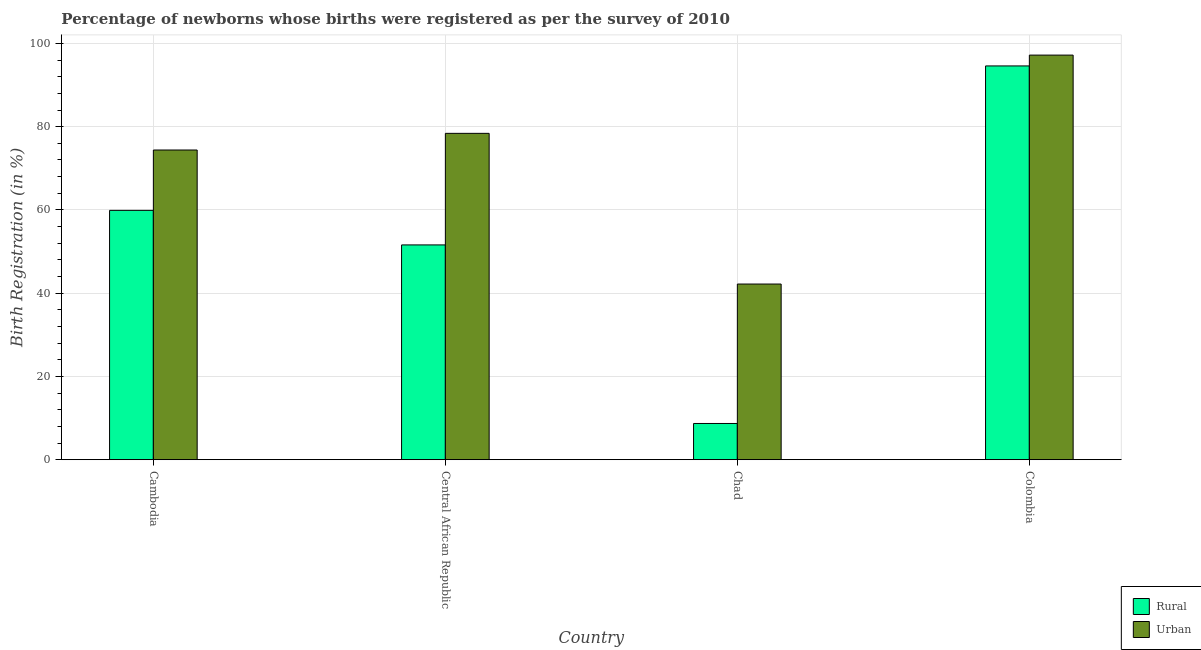How many different coloured bars are there?
Ensure brevity in your answer.  2. How many bars are there on the 3rd tick from the left?
Make the answer very short. 2. How many bars are there on the 3rd tick from the right?
Keep it short and to the point. 2. What is the label of the 3rd group of bars from the left?
Offer a terse response. Chad. What is the urban birth registration in Chad?
Provide a succinct answer. 42.2. Across all countries, what is the maximum urban birth registration?
Your answer should be very brief. 97.2. Across all countries, what is the minimum urban birth registration?
Give a very brief answer. 42.2. In which country was the urban birth registration maximum?
Your response must be concise. Colombia. In which country was the rural birth registration minimum?
Ensure brevity in your answer.  Chad. What is the total urban birth registration in the graph?
Keep it short and to the point. 292.2. What is the difference between the rural birth registration in Central African Republic and that in Chad?
Ensure brevity in your answer.  42.9. What is the difference between the urban birth registration in Cambodia and the rural birth registration in Central African Republic?
Your answer should be compact. 22.8. What is the average rural birth registration per country?
Provide a succinct answer. 53.7. What is the difference between the rural birth registration and urban birth registration in Central African Republic?
Offer a very short reply. -26.8. What is the ratio of the urban birth registration in Cambodia to that in Chad?
Keep it short and to the point. 1.76. Is the urban birth registration in Cambodia less than that in Chad?
Provide a succinct answer. No. Is the difference between the rural birth registration in Cambodia and Chad greater than the difference between the urban birth registration in Cambodia and Chad?
Ensure brevity in your answer.  Yes. What is the difference between the highest and the second highest rural birth registration?
Your response must be concise. 34.7. What is the difference between the highest and the lowest rural birth registration?
Offer a very short reply. 85.9. In how many countries, is the rural birth registration greater than the average rural birth registration taken over all countries?
Offer a terse response. 2. Is the sum of the urban birth registration in Central African Republic and Colombia greater than the maximum rural birth registration across all countries?
Provide a short and direct response. Yes. What does the 2nd bar from the left in Chad represents?
Offer a very short reply. Urban. What does the 1st bar from the right in Colombia represents?
Your answer should be very brief. Urban. Does the graph contain any zero values?
Give a very brief answer. No. How are the legend labels stacked?
Give a very brief answer. Vertical. What is the title of the graph?
Ensure brevity in your answer.  Percentage of newborns whose births were registered as per the survey of 2010. What is the label or title of the X-axis?
Give a very brief answer. Country. What is the label or title of the Y-axis?
Make the answer very short. Birth Registration (in %). What is the Birth Registration (in %) in Rural in Cambodia?
Provide a short and direct response. 59.9. What is the Birth Registration (in %) of Urban in Cambodia?
Provide a succinct answer. 74.4. What is the Birth Registration (in %) of Rural in Central African Republic?
Your answer should be very brief. 51.6. What is the Birth Registration (in %) of Urban in Central African Republic?
Keep it short and to the point. 78.4. What is the Birth Registration (in %) of Rural in Chad?
Give a very brief answer. 8.7. What is the Birth Registration (in %) of Urban in Chad?
Give a very brief answer. 42.2. What is the Birth Registration (in %) in Rural in Colombia?
Give a very brief answer. 94.6. What is the Birth Registration (in %) of Urban in Colombia?
Your answer should be very brief. 97.2. Across all countries, what is the maximum Birth Registration (in %) of Rural?
Make the answer very short. 94.6. Across all countries, what is the maximum Birth Registration (in %) of Urban?
Your answer should be very brief. 97.2. Across all countries, what is the minimum Birth Registration (in %) in Urban?
Provide a short and direct response. 42.2. What is the total Birth Registration (in %) in Rural in the graph?
Your answer should be compact. 214.8. What is the total Birth Registration (in %) of Urban in the graph?
Make the answer very short. 292.2. What is the difference between the Birth Registration (in %) of Rural in Cambodia and that in Chad?
Provide a short and direct response. 51.2. What is the difference between the Birth Registration (in %) in Urban in Cambodia and that in Chad?
Offer a very short reply. 32.2. What is the difference between the Birth Registration (in %) in Rural in Cambodia and that in Colombia?
Offer a very short reply. -34.7. What is the difference between the Birth Registration (in %) in Urban in Cambodia and that in Colombia?
Give a very brief answer. -22.8. What is the difference between the Birth Registration (in %) in Rural in Central African Republic and that in Chad?
Offer a terse response. 42.9. What is the difference between the Birth Registration (in %) in Urban in Central African Republic and that in Chad?
Your response must be concise. 36.2. What is the difference between the Birth Registration (in %) of Rural in Central African Republic and that in Colombia?
Offer a terse response. -43. What is the difference between the Birth Registration (in %) of Urban in Central African Republic and that in Colombia?
Your answer should be very brief. -18.8. What is the difference between the Birth Registration (in %) in Rural in Chad and that in Colombia?
Provide a succinct answer. -85.9. What is the difference between the Birth Registration (in %) of Urban in Chad and that in Colombia?
Your answer should be very brief. -55. What is the difference between the Birth Registration (in %) in Rural in Cambodia and the Birth Registration (in %) in Urban in Central African Republic?
Offer a terse response. -18.5. What is the difference between the Birth Registration (in %) in Rural in Cambodia and the Birth Registration (in %) in Urban in Chad?
Your response must be concise. 17.7. What is the difference between the Birth Registration (in %) of Rural in Cambodia and the Birth Registration (in %) of Urban in Colombia?
Your answer should be compact. -37.3. What is the difference between the Birth Registration (in %) in Rural in Central African Republic and the Birth Registration (in %) in Urban in Chad?
Keep it short and to the point. 9.4. What is the difference between the Birth Registration (in %) of Rural in Central African Republic and the Birth Registration (in %) of Urban in Colombia?
Keep it short and to the point. -45.6. What is the difference between the Birth Registration (in %) of Rural in Chad and the Birth Registration (in %) of Urban in Colombia?
Provide a short and direct response. -88.5. What is the average Birth Registration (in %) in Rural per country?
Your answer should be compact. 53.7. What is the average Birth Registration (in %) of Urban per country?
Your answer should be compact. 73.05. What is the difference between the Birth Registration (in %) of Rural and Birth Registration (in %) of Urban in Cambodia?
Ensure brevity in your answer.  -14.5. What is the difference between the Birth Registration (in %) in Rural and Birth Registration (in %) in Urban in Central African Republic?
Your answer should be very brief. -26.8. What is the difference between the Birth Registration (in %) of Rural and Birth Registration (in %) of Urban in Chad?
Give a very brief answer. -33.5. What is the ratio of the Birth Registration (in %) of Rural in Cambodia to that in Central African Republic?
Offer a terse response. 1.16. What is the ratio of the Birth Registration (in %) of Urban in Cambodia to that in Central African Republic?
Provide a succinct answer. 0.95. What is the ratio of the Birth Registration (in %) in Rural in Cambodia to that in Chad?
Give a very brief answer. 6.89. What is the ratio of the Birth Registration (in %) of Urban in Cambodia to that in Chad?
Make the answer very short. 1.76. What is the ratio of the Birth Registration (in %) of Rural in Cambodia to that in Colombia?
Make the answer very short. 0.63. What is the ratio of the Birth Registration (in %) in Urban in Cambodia to that in Colombia?
Offer a terse response. 0.77. What is the ratio of the Birth Registration (in %) of Rural in Central African Republic to that in Chad?
Ensure brevity in your answer.  5.93. What is the ratio of the Birth Registration (in %) of Urban in Central African Republic to that in Chad?
Offer a very short reply. 1.86. What is the ratio of the Birth Registration (in %) in Rural in Central African Republic to that in Colombia?
Provide a succinct answer. 0.55. What is the ratio of the Birth Registration (in %) in Urban in Central African Republic to that in Colombia?
Ensure brevity in your answer.  0.81. What is the ratio of the Birth Registration (in %) of Rural in Chad to that in Colombia?
Your answer should be very brief. 0.09. What is the ratio of the Birth Registration (in %) of Urban in Chad to that in Colombia?
Give a very brief answer. 0.43. What is the difference between the highest and the second highest Birth Registration (in %) in Rural?
Offer a very short reply. 34.7. What is the difference between the highest and the second highest Birth Registration (in %) of Urban?
Keep it short and to the point. 18.8. What is the difference between the highest and the lowest Birth Registration (in %) in Rural?
Make the answer very short. 85.9. What is the difference between the highest and the lowest Birth Registration (in %) in Urban?
Provide a short and direct response. 55. 